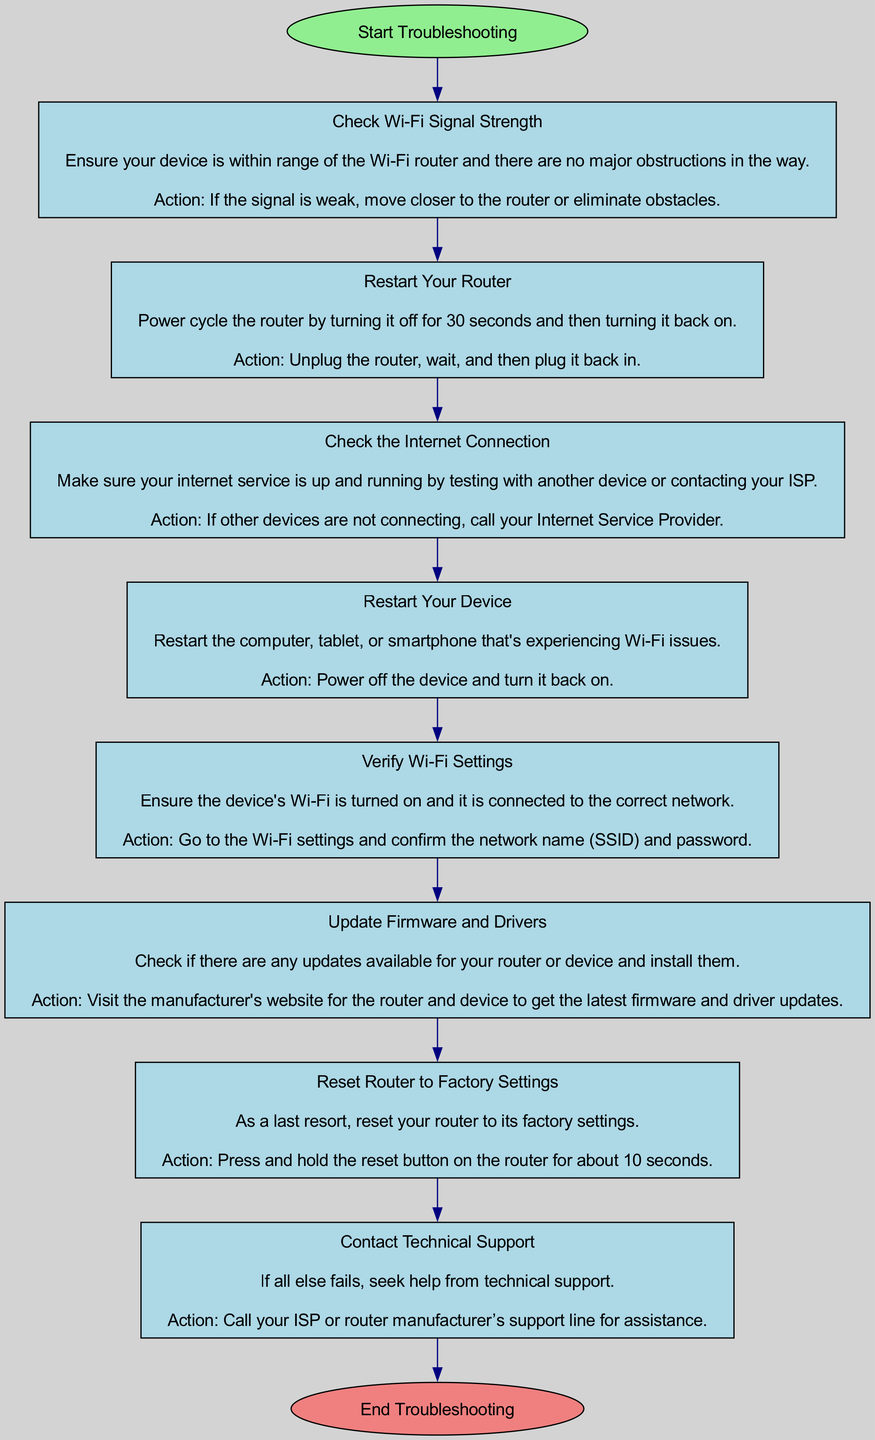What is the first step in troubleshooting a Wi-Fi network? The first step is labeled "Check Wi-Fi Signal Strength" and appears directly after the "Start Troubleshooting" node, indicating it is the initial action to take.
Answer: Check Wi-Fi Signal Strength How many total steps are in the troubleshooting process? By counting the nodes for each step from the start to the end node, there are eight steps listed in the diagram before reaching the "End Troubleshooting."
Answer: Eight Which step comes after "Restart Your Device"? The step that follows "Restart Your Device" is "Verify Wi-Fi Settings," as evidenced by the directed edge connecting the two steps in the flow of the chart.
Answer: Verify Wi-Fi Settings What action is suggested if the "Wi-Fi Signal Strength" is weak? The action indicated for weak signal strength is to "move closer to the router or eliminate obstacles," which is part of the step's description and action.
Answer: Move closer to the router or eliminate obstacles What should you do if other devices are not connecting to the internet? According to the "Check the Internet Connection" step, if other devices aren't connecting, the recommended action is to "call your Internet Service Provider."
Answer: Call your Internet Service Provider What is the last resort step in the troubleshooting process? The last resort step is labeled "Reset Router to Factory Settings," indicating that it should be undertaken only if previous steps do not resolve the issue.
Answer: Reset Router to Factory Settings Which step requires visiting a manufacturer's website? The "Update Firmware and Drivers" step specifies that checking for updates requires visiting the manufacturer's website to find and install the latest updates.
Answer: Update Firmware and Drivers What happens after "Reset Router to Factory Settings"? After "Reset Router to Factory Settings," the next step is to "Contact Technical Support," indicating that further help is needed if issues persist.
Answer: Contact Technical Support 